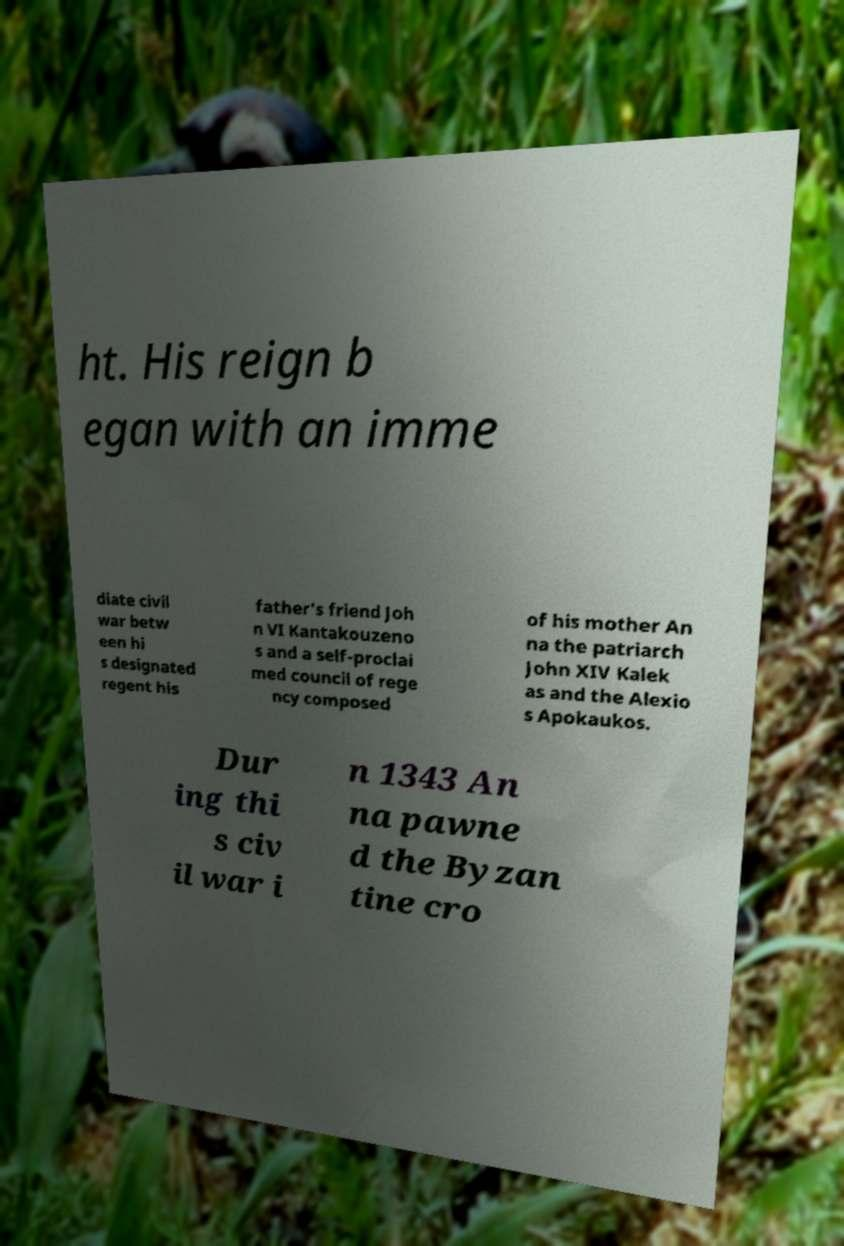Can you accurately transcribe the text from the provided image for me? ht. His reign b egan with an imme diate civil war betw een hi s designated regent his father's friend Joh n VI Kantakouzeno s and a self-proclai med council of rege ncy composed of his mother An na the patriarch John XIV Kalek as and the Alexio s Apokaukos. Dur ing thi s civ il war i n 1343 An na pawne d the Byzan tine cro 